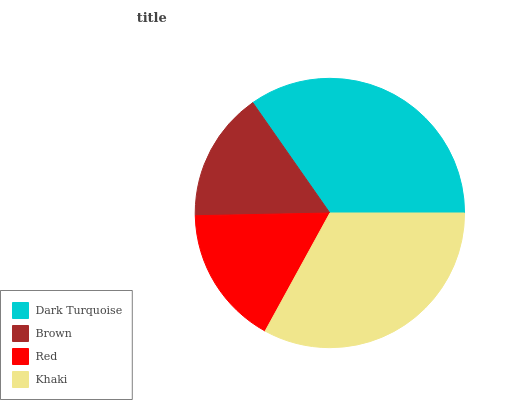Is Brown the minimum?
Answer yes or no. Yes. Is Dark Turquoise the maximum?
Answer yes or no. Yes. Is Red the minimum?
Answer yes or no. No. Is Red the maximum?
Answer yes or no. No. Is Red greater than Brown?
Answer yes or no. Yes. Is Brown less than Red?
Answer yes or no. Yes. Is Brown greater than Red?
Answer yes or no. No. Is Red less than Brown?
Answer yes or no. No. Is Khaki the high median?
Answer yes or no. Yes. Is Red the low median?
Answer yes or no. Yes. Is Red the high median?
Answer yes or no. No. Is Dark Turquoise the low median?
Answer yes or no. No. 